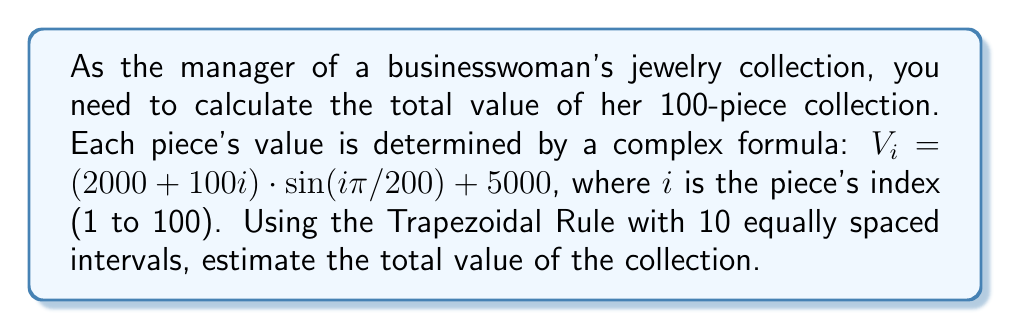Give your solution to this math problem. To solve this problem, we'll use the Trapezoidal Rule for numerical integration:

1) The Trapezoidal Rule formula is:

   $$\int_{a}^{b} f(x)dx \approx \frac{h}{2}[f(x_0) + 2f(x_1) + 2f(x_2) + ... + 2f(x_{n-1}) + f(x_n)]$$

   where $h = \frac{b-a}{n}$, and $n$ is the number of intervals.

2) In our case:
   $a = 1$, $b = 100$, $n = 10$
   $h = \frac{100-1}{10} = 9.9$

3) We need to evaluate the function at 11 points: $x_0 = 1$, $x_1 = 10.9$, $x_2 = 20.8$, ..., $x_{10} = 100$

4) Let's calculate these values:
   $f(1) = (2000 + 100(1)) \cdot \sin(1\pi/200) + 5000 = 5157.08$
   $f(10.9) = (2000 + 100(10.9)) \cdot \sin(10.9\pi/200) + 5000 = 6641.76$
   ...
   $f(100) = (2000 + 100(100)) \cdot \sin(100\pi/200) + 5000 = 17000$

5) Applying the Trapezoidal Rule:

   $$\text{Total Value} \approx \frac{9.9}{2}[5157.08 + 2(6641.76 + ... + 16034.48) + 17000]$$

6) Calculating this sum:

   $$\text{Total Value} \approx 1,089,891.53$$

Therefore, the estimated total value of the jewelry collection is approximately $1,089,891.53.
Answer: $1,089,891.53 